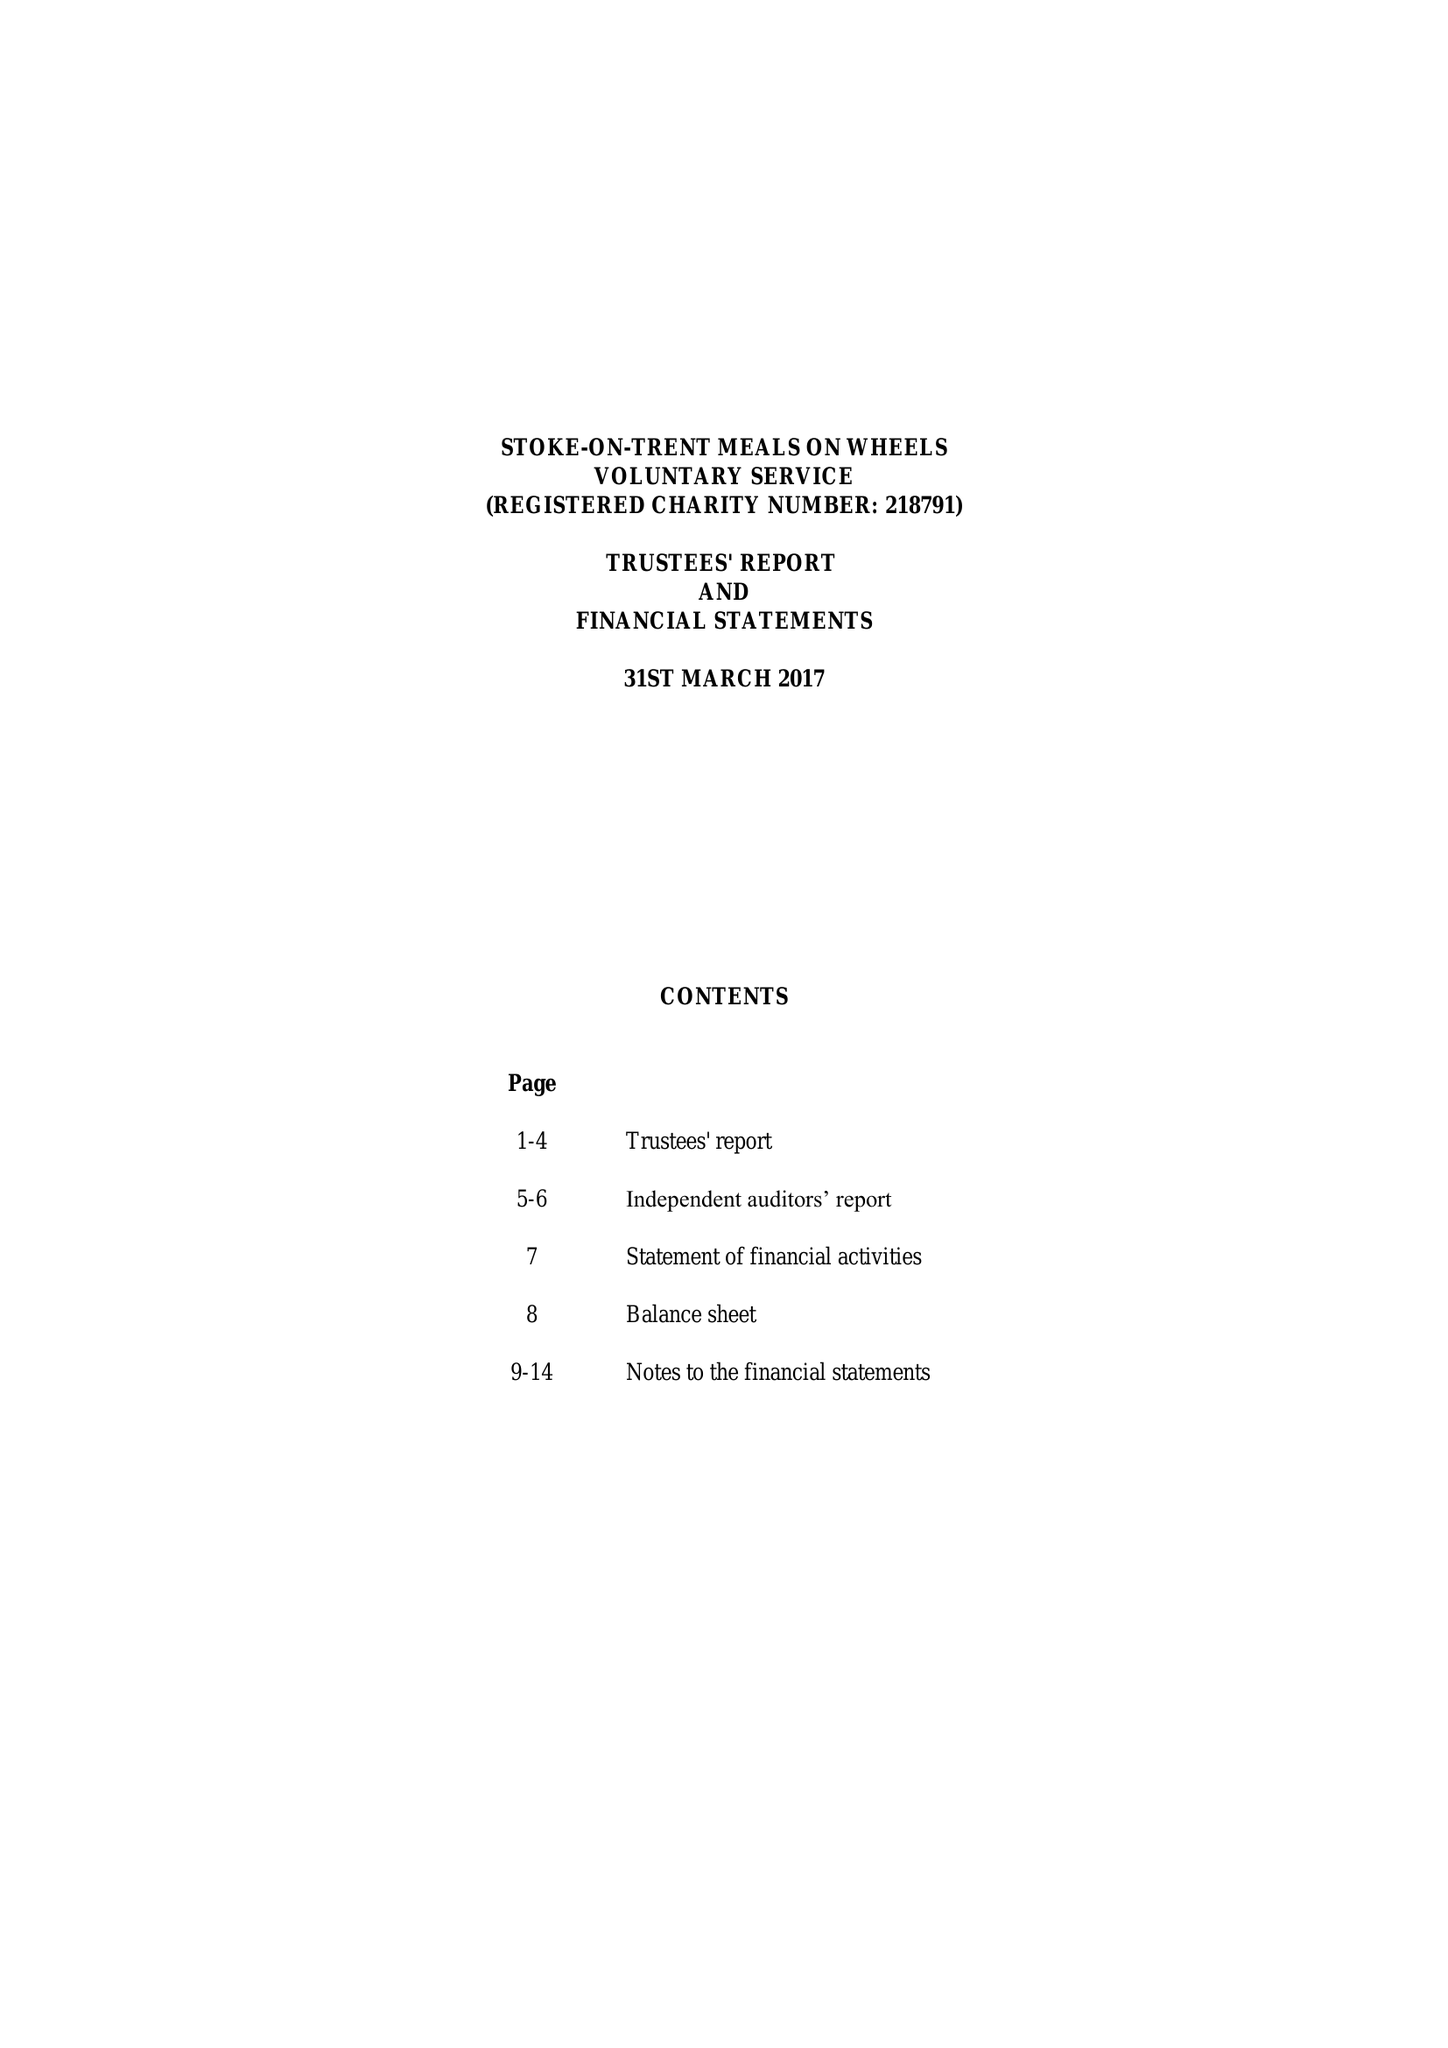What is the value for the spending_annually_in_british_pounds?
Answer the question using a single word or phrase. 94570.00 